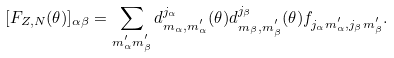Convert formula to latex. <formula><loc_0><loc_0><loc_500><loc_500>[ F _ { Z , N } ( \theta ) ] _ { \alpha \beta } = \sum _ { m _ { \alpha } ^ { ^ { \prime } } m _ { \beta } ^ { ^ { \prime } } } d _ { m _ { \alpha } , m _ { \alpha } ^ { ^ { \prime } } } ^ { j _ { \alpha } } ( \theta ) d _ { m _ { \beta } , m _ { \beta } ^ { ^ { \prime } } } ^ { j _ { \beta } } ( \theta ) f _ { j _ { \alpha } m _ { \alpha } ^ { ^ { \prime } } , j _ { \beta } m _ { \beta } ^ { ^ { \prime } } } .</formula> 